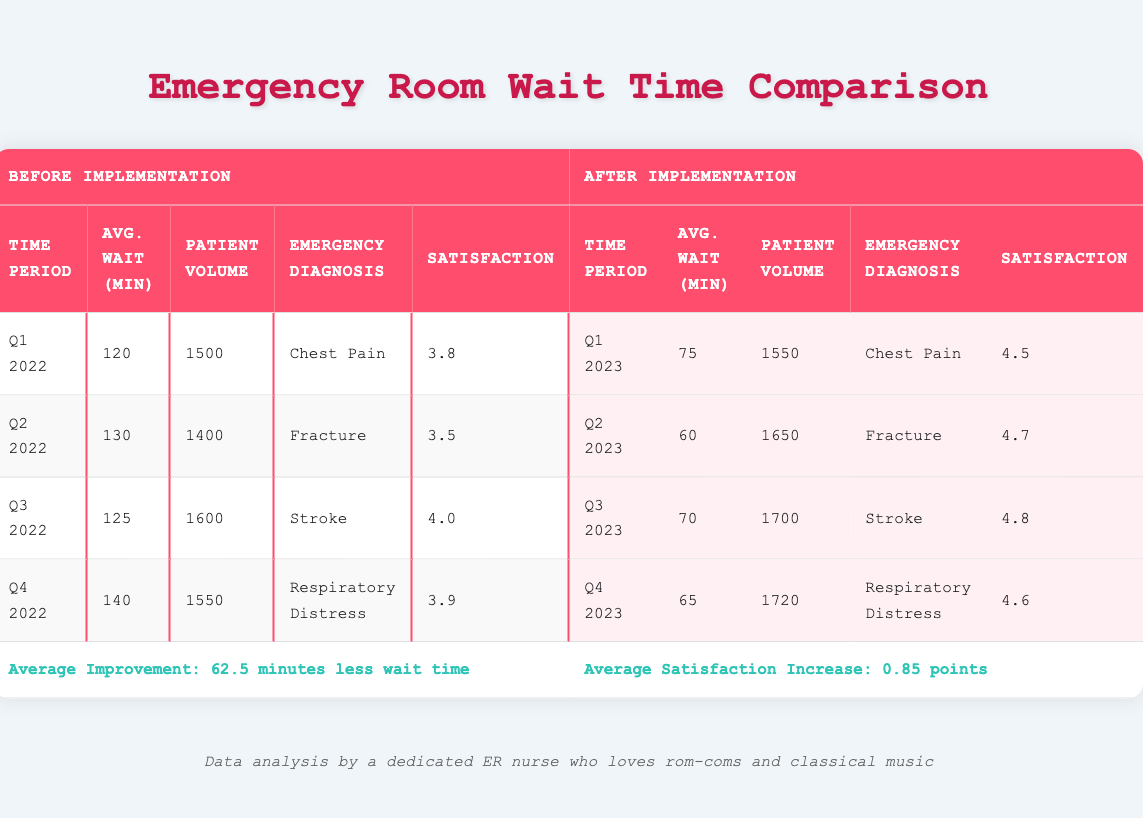What was the average wait time for chest pain patients before the implementation of the triage system? The table shows that the average wait time for chest pain patients in Q1 2022 was 120 minutes.
Answer: 120 minutes How many patients were treated for fractures after the implementation of the triage system? The table indicates that in Q2 2023, 1650 patients were treated for fractures after the triage system was implemented.
Answer: 1650 patients What is the difference in satisfaction scores for respiratory distress patients before and after the implementation? Before implementation in Q4 2022, the satisfaction score was 3.9, and after implementation in Q4 2023, it increased to 4.6. The difference is 4.6 - 3.9 = 0.7.
Answer: 0.7 Is the average wait time for stroke patients higher before or after the implementation? In Q3 2022, the average wait time for stroke patients was 125 minutes, while in Q3 2023, it decreased to 70 minutes after implementation. Therefore, the wait time was higher before implementation.
Answer: Yes, higher before implementation What is the average patient volume before the implementation of the triage system? To find the average, add the patient volumes of all periods before implementation: (1500 + 1400 + 1600 + 1550) = 6050. Then divide by 4 (number of periods): 6050 / 4 = 1512.5.
Answer: 1512.5 patients What period saw the greatest decrease in average wait time after implementing the triage system? Comparing the wait times after implementation, Q2 2023 had an average wait time of 60 minutes, which is lower than Q1 2023 (75 minutes) or the following quarters, indicating it had the greatest decrease.
Answer: Q2 2023 Was there an overall improvement in satisfaction scores after the implementation of the triage system? Before implementation, the average satisfaction score was 3.8, 3.5, 4.0, and 3.9, which averages to 3.78. After implementation, the averages were 4.5, 4.7, 4.8, and 4.6, averaging to 4.54, so there was an improvement.
Answer: Yes What is the average wait time for patients with respiratory distress before the triage implementation? The average wait time for respiratory distress patients was 140 minutes in Q4 2022 before implementation.
Answer: 140 minutes 